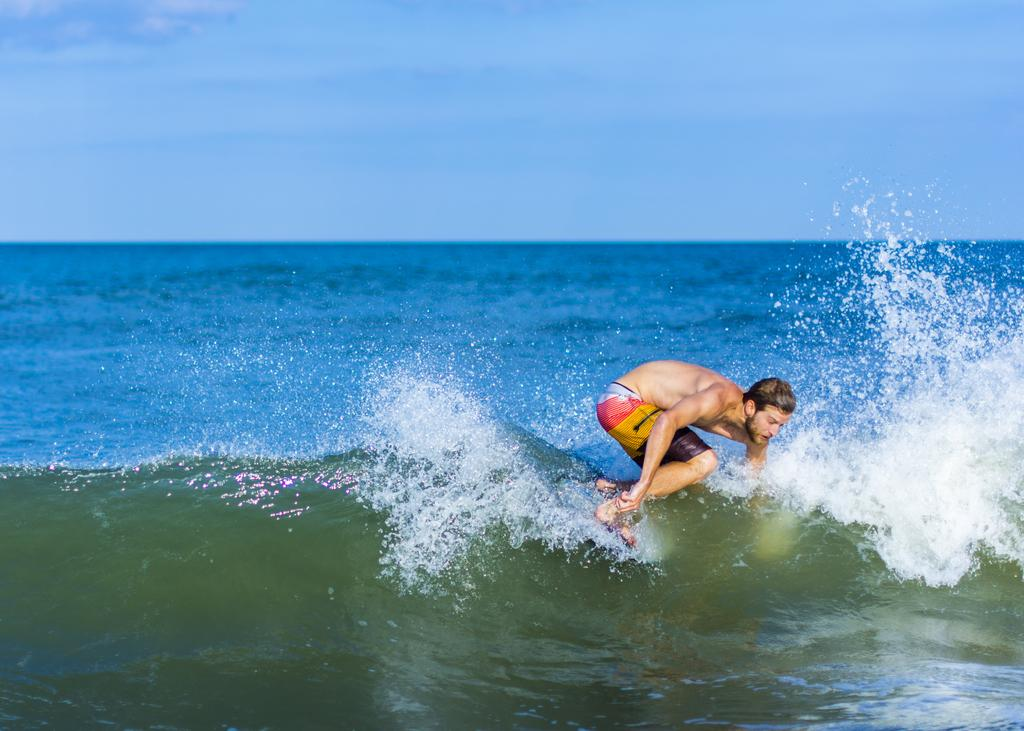What is the main activity being performed in the image? There is a person surfing in the image. Where is the person surfing? The person is on the surface of the water. What can be seen in the background of the image? The sky is visible in the background of the image. What type of locket is the person wearing while surfing in the image? There is no locket visible in the image; the person is surfing and wearing a wetsuit or swimwear. 